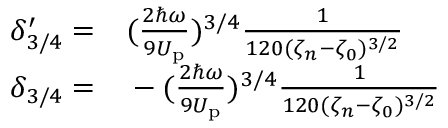Convert formula to latex. <formula><loc_0><loc_0><loc_500><loc_500>\begin{array} { r l } { \delta _ { 3 / 4 } ^ { \prime } = } & ( \frac { 2 \hbar { \omega } } { 9 U _ { p } } ) ^ { 3 / 4 } \frac { 1 } { 1 2 0 ( \zeta _ { n } - \zeta _ { 0 } ) ^ { 3 / 2 } } } \\ { \delta _ { 3 / 4 } = } & - ( \frac { 2 \hbar { \omega } } { 9 U _ { p } } ) ^ { 3 / 4 } \frac { 1 } { 1 2 0 ( \zeta _ { n } - \zeta _ { 0 } ) ^ { 3 / 2 } } } \end{array}</formula> 